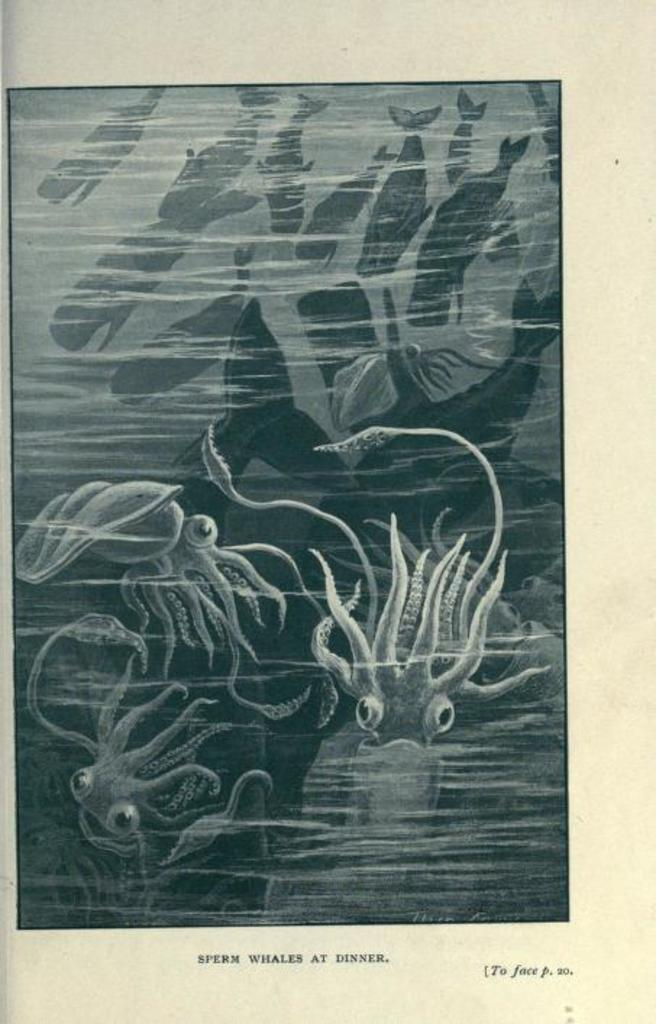What type of animals are featured in the image? The image contains a depiction of aquatic animals. Can you describe any additional elements in the image? There is text written on the bottom side of the image. How does the grip of the class affect the bath in the image? There is no mention of a grip, class, or bath in the image, so this question cannot be answered based on the provided facts. 